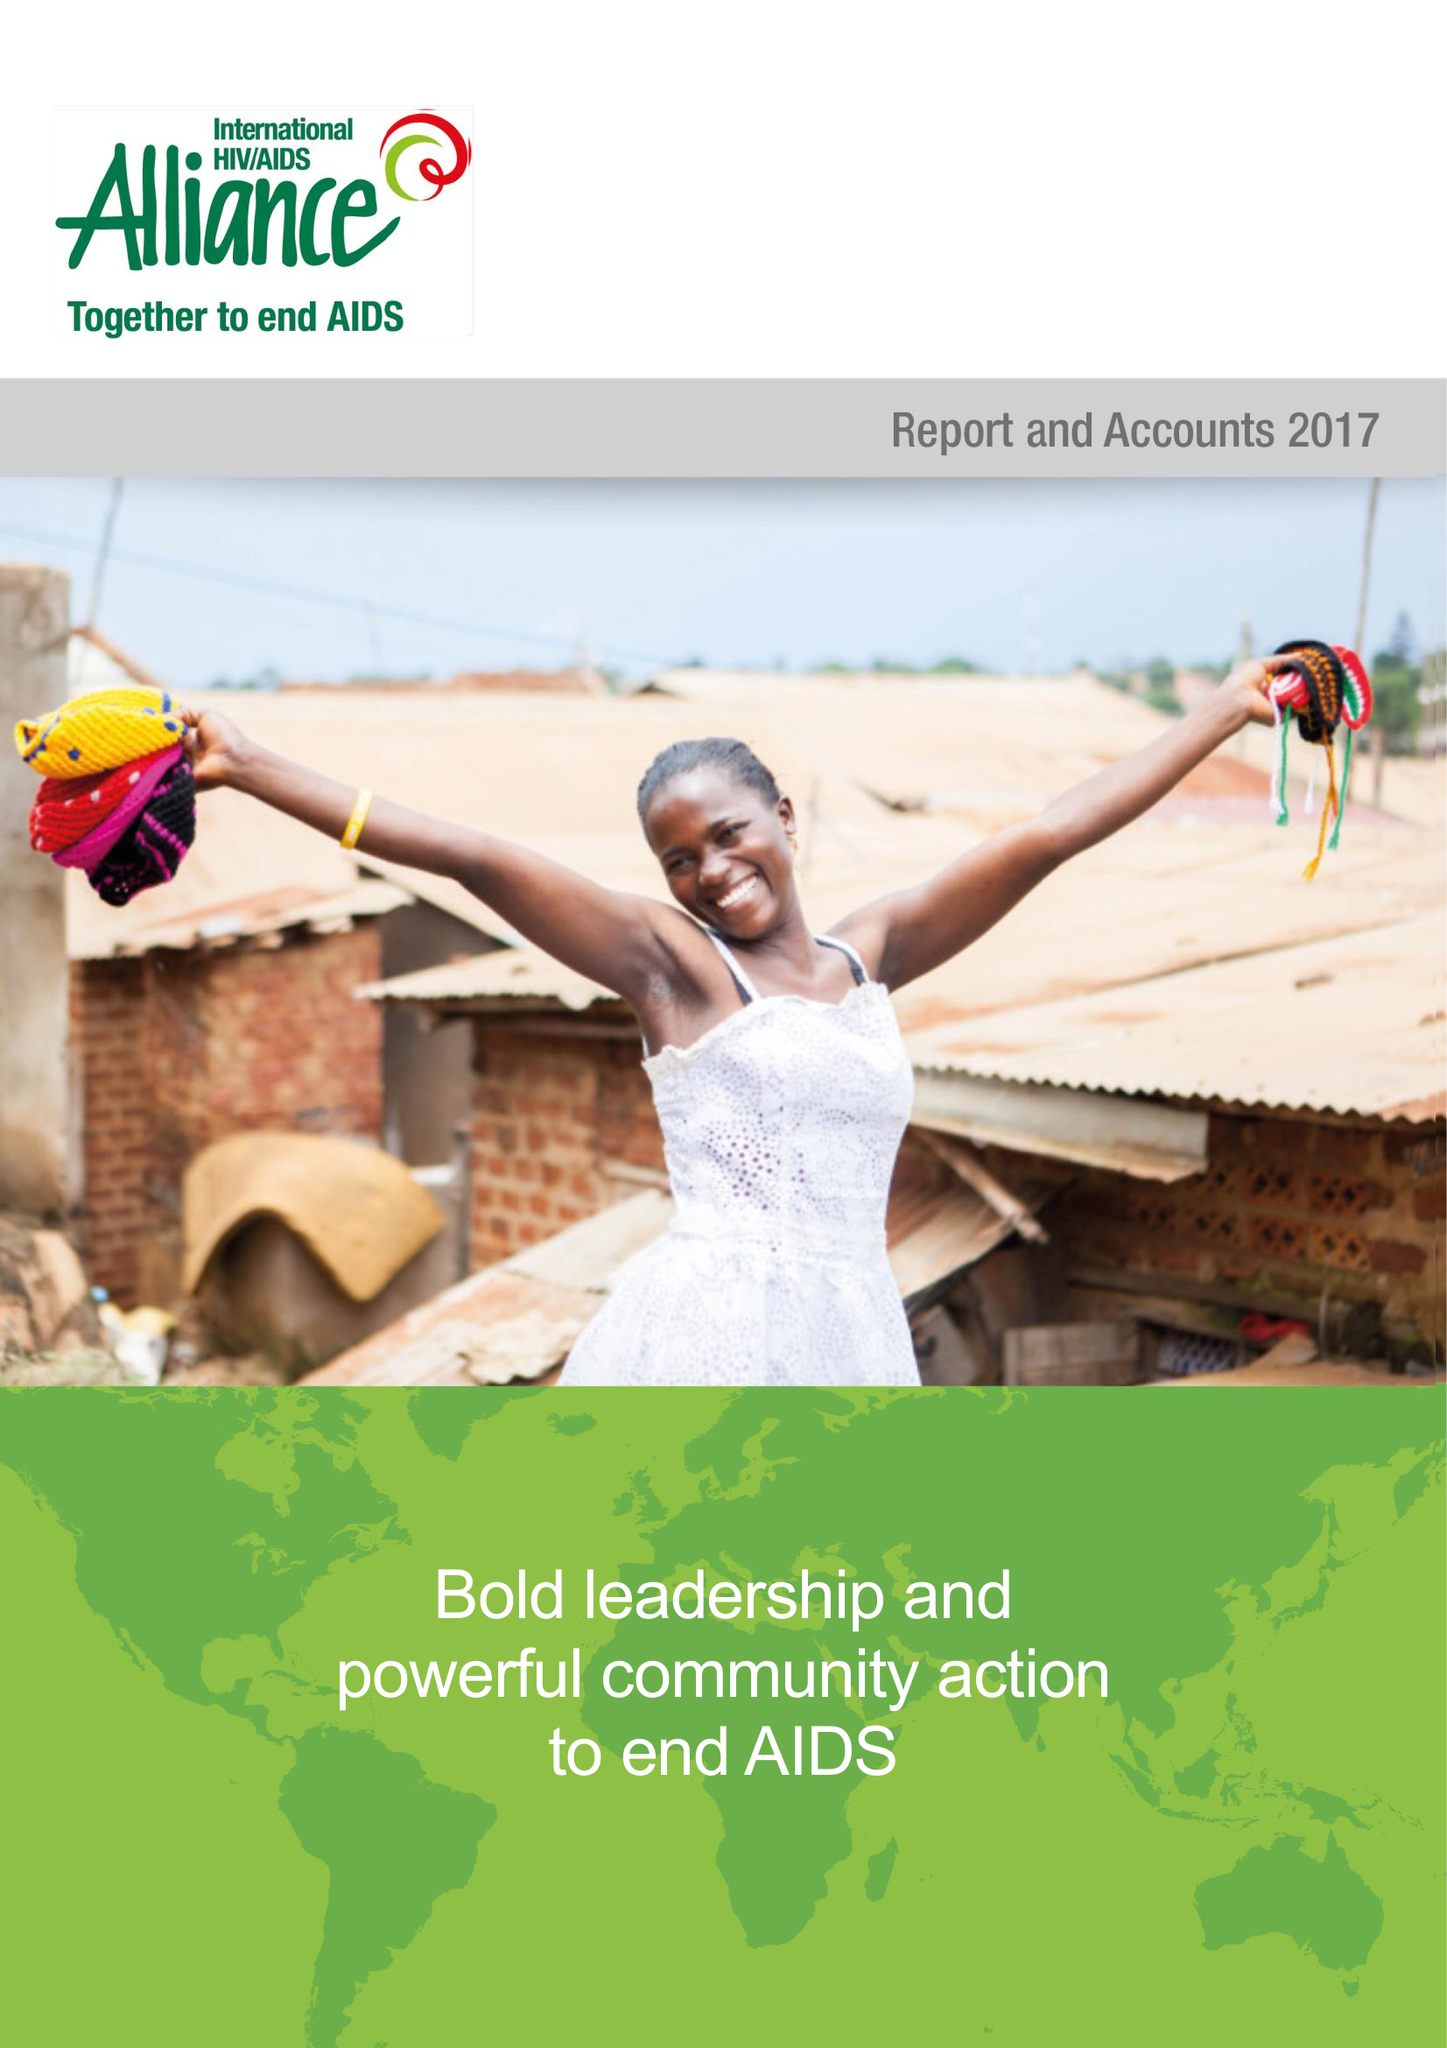What is the value for the income_annually_in_british_pounds?
Answer the question using a single word or phrase. 19085196.00 